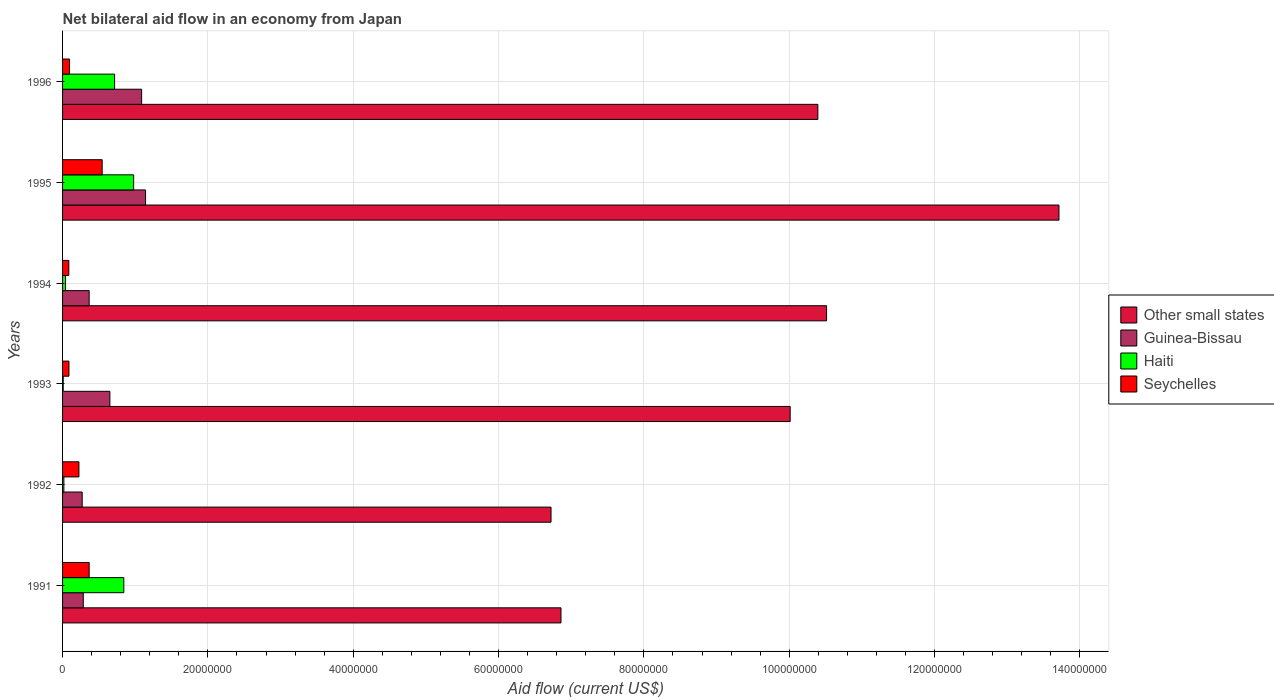How many different coloured bars are there?
Offer a terse response. 4. Are the number of bars per tick equal to the number of legend labels?
Provide a succinct answer. Yes. Are the number of bars on each tick of the Y-axis equal?
Offer a terse response. Yes. How many bars are there on the 3rd tick from the top?
Your answer should be very brief. 4. In how many cases, is the number of bars for a given year not equal to the number of legend labels?
Your answer should be compact. 0. What is the net bilateral aid flow in Haiti in 1995?
Make the answer very short. 9.78e+06. Across all years, what is the maximum net bilateral aid flow in Haiti?
Your answer should be compact. 9.78e+06. Across all years, what is the minimum net bilateral aid flow in Seychelles?
Keep it short and to the point. 8.60e+05. In which year was the net bilateral aid flow in Guinea-Bissau maximum?
Offer a terse response. 1995. What is the total net bilateral aid flow in Other small states in the graph?
Offer a terse response. 5.82e+08. What is the difference between the net bilateral aid flow in Seychelles in 1991 and that in 1995?
Make the answer very short. -1.79e+06. What is the difference between the net bilateral aid flow in Haiti in 1992 and the net bilateral aid flow in Other small states in 1994?
Offer a very short reply. -1.05e+08. What is the average net bilateral aid flow in Guinea-Bissau per year?
Keep it short and to the point. 6.34e+06. In the year 1991, what is the difference between the net bilateral aid flow in Other small states and net bilateral aid flow in Haiti?
Give a very brief answer. 6.02e+07. What is the ratio of the net bilateral aid flow in Haiti in 1991 to that in 1994?
Your answer should be compact. 20.56. What is the difference between the highest and the second highest net bilateral aid flow in Guinea-Bissau?
Provide a short and direct response. 5.40e+05. What is the difference between the highest and the lowest net bilateral aid flow in Seychelles?
Provide a succinct answer. 4.59e+06. In how many years, is the net bilateral aid flow in Other small states greater than the average net bilateral aid flow in Other small states taken over all years?
Provide a short and direct response. 4. Is the sum of the net bilateral aid flow in Guinea-Bissau in 1993 and 1994 greater than the maximum net bilateral aid flow in Other small states across all years?
Ensure brevity in your answer.  No. What does the 2nd bar from the top in 1996 represents?
Make the answer very short. Haiti. What does the 4th bar from the bottom in 1992 represents?
Offer a very short reply. Seychelles. Are all the bars in the graph horizontal?
Ensure brevity in your answer.  Yes. How many years are there in the graph?
Provide a succinct answer. 6. Does the graph contain any zero values?
Offer a very short reply. No. How are the legend labels stacked?
Your response must be concise. Vertical. What is the title of the graph?
Make the answer very short. Net bilateral aid flow in an economy from Japan. What is the label or title of the Y-axis?
Your answer should be very brief. Years. What is the Aid flow (current US$) in Other small states in 1991?
Your answer should be very brief. 6.86e+07. What is the Aid flow (current US$) of Guinea-Bissau in 1991?
Your answer should be very brief. 2.85e+06. What is the Aid flow (current US$) in Haiti in 1991?
Offer a terse response. 8.43e+06. What is the Aid flow (current US$) of Seychelles in 1991?
Give a very brief answer. 3.66e+06. What is the Aid flow (current US$) in Other small states in 1992?
Your answer should be compact. 6.72e+07. What is the Aid flow (current US$) of Guinea-Bissau in 1992?
Make the answer very short. 2.70e+06. What is the Aid flow (current US$) of Haiti in 1992?
Make the answer very short. 1.80e+05. What is the Aid flow (current US$) of Seychelles in 1992?
Offer a very short reply. 2.25e+06. What is the Aid flow (current US$) in Other small states in 1993?
Offer a terse response. 1.00e+08. What is the Aid flow (current US$) in Guinea-Bissau in 1993?
Offer a very short reply. 6.51e+06. What is the Aid flow (current US$) of Haiti in 1993?
Provide a succinct answer. 9.00e+04. What is the Aid flow (current US$) in Seychelles in 1993?
Your answer should be very brief. 8.80e+05. What is the Aid flow (current US$) of Other small states in 1994?
Give a very brief answer. 1.05e+08. What is the Aid flow (current US$) in Guinea-Bissau in 1994?
Give a very brief answer. 3.66e+06. What is the Aid flow (current US$) in Haiti in 1994?
Ensure brevity in your answer.  4.10e+05. What is the Aid flow (current US$) of Seychelles in 1994?
Provide a short and direct response. 8.60e+05. What is the Aid flow (current US$) in Other small states in 1995?
Provide a short and direct response. 1.37e+08. What is the Aid flow (current US$) of Guinea-Bissau in 1995?
Keep it short and to the point. 1.14e+07. What is the Aid flow (current US$) of Haiti in 1995?
Give a very brief answer. 9.78e+06. What is the Aid flow (current US$) of Seychelles in 1995?
Keep it short and to the point. 5.45e+06. What is the Aid flow (current US$) of Other small states in 1996?
Offer a terse response. 1.04e+08. What is the Aid flow (current US$) of Guinea-Bissau in 1996?
Offer a terse response. 1.09e+07. What is the Aid flow (current US$) of Haiti in 1996?
Keep it short and to the point. 7.16e+06. What is the Aid flow (current US$) of Seychelles in 1996?
Offer a very short reply. 9.60e+05. Across all years, what is the maximum Aid flow (current US$) in Other small states?
Make the answer very short. 1.37e+08. Across all years, what is the maximum Aid flow (current US$) in Guinea-Bissau?
Keep it short and to the point. 1.14e+07. Across all years, what is the maximum Aid flow (current US$) in Haiti?
Your response must be concise. 9.78e+06. Across all years, what is the maximum Aid flow (current US$) of Seychelles?
Offer a terse response. 5.45e+06. Across all years, what is the minimum Aid flow (current US$) of Other small states?
Offer a terse response. 6.72e+07. Across all years, what is the minimum Aid flow (current US$) of Guinea-Bissau?
Your answer should be very brief. 2.70e+06. Across all years, what is the minimum Aid flow (current US$) of Haiti?
Offer a very short reply. 9.00e+04. Across all years, what is the minimum Aid flow (current US$) in Seychelles?
Your response must be concise. 8.60e+05. What is the total Aid flow (current US$) of Other small states in the graph?
Offer a terse response. 5.82e+08. What is the total Aid flow (current US$) in Guinea-Bissau in the graph?
Ensure brevity in your answer.  3.80e+07. What is the total Aid flow (current US$) in Haiti in the graph?
Provide a short and direct response. 2.60e+07. What is the total Aid flow (current US$) of Seychelles in the graph?
Your response must be concise. 1.41e+07. What is the difference between the Aid flow (current US$) in Other small states in 1991 and that in 1992?
Your response must be concise. 1.37e+06. What is the difference between the Aid flow (current US$) in Haiti in 1991 and that in 1992?
Provide a short and direct response. 8.25e+06. What is the difference between the Aid flow (current US$) of Seychelles in 1991 and that in 1992?
Give a very brief answer. 1.41e+06. What is the difference between the Aid flow (current US$) of Other small states in 1991 and that in 1993?
Your answer should be very brief. -3.15e+07. What is the difference between the Aid flow (current US$) of Guinea-Bissau in 1991 and that in 1993?
Keep it short and to the point. -3.66e+06. What is the difference between the Aid flow (current US$) in Haiti in 1991 and that in 1993?
Make the answer very short. 8.34e+06. What is the difference between the Aid flow (current US$) of Seychelles in 1991 and that in 1993?
Your answer should be very brief. 2.78e+06. What is the difference between the Aid flow (current US$) in Other small states in 1991 and that in 1994?
Offer a very short reply. -3.66e+07. What is the difference between the Aid flow (current US$) in Guinea-Bissau in 1991 and that in 1994?
Offer a terse response. -8.10e+05. What is the difference between the Aid flow (current US$) of Haiti in 1991 and that in 1994?
Keep it short and to the point. 8.02e+06. What is the difference between the Aid flow (current US$) in Seychelles in 1991 and that in 1994?
Keep it short and to the point. 2.80e+06. What is the difference between the Aid flow (current US$) in Other small states in 1991 and that in 1995?
Provide a short and direct response. -6.85e+07. What is the difference between the Aid flow (current US$) in Guinea-Bissau in 1991 and that in 1995?
Provide a short and direct response. -8.57e+06. What is the difference between the Aid flow (current US$) in Haiti in 1991 and that in 1995?
Your response must be concise. -1.35e+06. What is the difference between the Aid flow (current US$) of Seychelles in 1991 and that in 1995?
Give a very brief answer. -1.79e+06. What is the difference between the Aid flow (current US$) of Other small states in 1991 and that in 1996?
Make the answer very short. -3.54e+07. What is the difference between the Aid flow (current US$) of Guinea-Bissau in 1991 and that in 1996?
Ensure brevity in your answer.  -8.03e+06. What is the difference between the Aid flow (current US$) in Haiti in 1991 and that in 1996?
Your answer should be compact. 1.27e+06. What is the difference between the Aid flow (current US$) of Seychelles in 1991 and that in 1996?
Your response must be concise. 2.70e+06. What is the difference between the Aid flow (current US$) of Other small states in 1992 and that in 1993?
Provide a succinct answer. -3.29e+07. What is the difference between the Aid flow (current US$) of Guinea-Bissau in 1992 and that in 1993?
Provide a short and direct response. -3.81e+06. What is the difference between the Aid flow (current US$) of Haiti in 1992 and that in 1993?
Keep it short and to the point. 9.00e+04. What is the difference between the Aid flow (current US$) in Seychelles in 1992 and that in 1993?
Make the answer very short. 1.37e+06. What is the difference between the Aid flow (current US$) in Other small states in 1992 and that in 1994?
Offer a terse response. -3.79e+07. What is the difference between the Aid flow (current US$) in Guinea-Bissau in 1992 and that in 1994?
Give a very brief answer. -9.60e+05. What is the difference between the Aid flow (current US$) of Seychelles in 1992 and that in 1994?
Provide a succinct answer. 1.39e+06. What is the difference between the Aid flow (current US$) of Other small states in 1992 and that in 1995?
Provide a succinct answer. -6.99e+07. What is the difference between the Aid flow (current US$) in Guinea-Bissau in 1992 and that in 1995?
Provide a succinct answer. -8.72e+06. What is the difference between the Aid flow (current US$) of Haiti in 1992 and that in 1995?
Ensure brevity in your answer.  -9.60e+06. What is the difference between the Aid flow (current US$) of Seychelles in 1992 and that in 1995?
Make the answer very short. -3.20e+06. What is the difference between the Aid flow (current US$) of Other small states in 1992 and that in 1996?
Provide a short and direct response. -3.67e+07. What is the difference between the Aid flow (current US$) in Guinea-Bissau in 1992 and that in 1996?
Ensure brevity in your answer.  -8.18e+06. What is the difference between the Aid flow (current US$) in Haiti in 1992 and that in 1996?
Provide a succinct answer. -6.98e+06. What is the difference between the Aid flow (current US$) of Seychelles in 1992 and that in 1996?
Keep it short and to the point. 1.29e+06. What is the difference between the Aid flow (current US$) of Other small states in 1993 and that in 1994?
Ensure brevity in your answer.  -5.01e+06. What is the difference between the Aid flow (current US$) in Guinea-Bissau in 1993 and that in 1994?
Provide a succinct answer. 2.85e+06. What is the difference between the Aid flow (current US$) in Haiti in 1993 and that in 1994?
Keep it short and to the point. -3.20e+05. What is the difference between the Aid flow (current US$) in Seychelles in 1993 and that in 1994?
Your response must be concise. 2.00e+04. What is the difference between the Aid flow (current US$) of Other small states in 1993 and that in 1995?
Ensure brevity in your answer.  -3.70e+07. What is the difference between the Aid flow (current US$) of Guinea-Bissau in 1993 and that in 1995?
Provide a succinct answer. -4.91e+06. What is the difference between the Aid flow (current US$) of Haiti in 1993 and that in 1995?
Give a very brief answer. -9.69e+06. What is the difference between the Aid flow (current US$) of Seychelles in 1993 and that in 1995?
Your answer should be very brief. -4.57e+06. What is the difference between the Aid flow (current US$) of Other small states in 1993 and that in 1996?
Provide a short and direct response. -3.81e+06. What is the difference between the Aid flow (current US$) of Guinea-Bissau in 1993 and that in 1996?
Your answer should be very brief. -4.37e+06. What is the difference between the Aid flow (current US$) of Haiti in 1993 and that in 1996?
Your answer should be compact. -7.07e+06. What is the difference between the Aid flow (current US$) in Seychelles in 1993 and that in 1996?
Ensure brevity in your answer.  -8.00e+04. What is the difference between the Aid flow (current US$) of Other small states in 1994 and that in 1995?
Your answer should be compact. -3.20e+07. What is the difference between the Aid flow (current US$) of Guinea-Bissau in 1994 and that in 1995?
Provide a short and direct response. -7.76e+06. What is the difference between the Aid flow (current US$) in Haiti in 1994 and that in 1995?
Give a very brief answer. -9.37e+06. What is the difference between the Aid flow (current US$) in Seychelles in 1994 and that in 1995?
Keep it short and to the point. -4.59e+06. What is the difference between the Aid flow (current US$) of Other small states in 1994 and that in 1996?
Provide a succinct answer. 1.20e+06. What is the difference between the Aid flow (current US$) of Guinea-Bissau in 1994 and that in 1996?
Ensure brevity in your answer.  -7.22e+06. What is the difference between the Aid flow (current US$) of Haiti in 1994 and that in 1996?
Offer a terse response. -6.75e+06. What is the difference between the Aid flow (current US$) in Other small states in 1995 and that in 1996?
Offer a terse response. 3.32e+07. What is the difference between the Aid flow (current US$) in Guinea-Bissau in 1995 and that in 1996?
Ensure brevity in your answer.  5.40e+05. What is the difference between the Aid flow (current US$) in Haiti in 1995 and that in 1996?
Make the answer very short. 2.62e+06. What is the difference between the Aid flow (current US$) of Seychelles in 1995 and that in 1996?
Make the answer very short. 4.49e+06. What is the difference between the Aid flow (current US$) in Other small states in 1991 and the Aid flow (current US$) in Guinea-Bissau in 1992?
Your response must be concise. 6.59e+07. What is the difference between the Aid flow (current US$) in Other small states in 1991 and the Aid flow (current US$) in Haiti in 1992?
Offer a terse response. 6.84e+07. What is the difference between the Aid flow (current US$) of Other small states in 1991 and the Aid flow (current US$) of Seychelles in 1992?
Offer a terse response. 6.63e+07. What is the difference between the Aid flow (current US$) of Guinea-Bissau in 1991 and the Aid flow (current US$) of Haiti in 1992?
Your answer should be compact. 2.67e+06. What is the difference between the Aid flow (current US$) of Haiti in 1991 and the Aid flow (current US$) of Seychelles in 1992?
Offer a very short reply. 6.18e+06. What is the difference between the Aid flow (current US$) of Other small states in 1991 and the Aid flow (current US$) of Guinea-Bissau in 1993?
Give a very brief answer. 6.21e+07. What is the difference between the Aid flow (current US$) in Other small states in 1991 and the Aid flow (current US$) in Haiti in 1993?
Give a very brief answer. 6.85e+07. What is the difference between the Aid flow (current US$) of Other small states in 1991 and the Aid flow (current US$) of Seychelles in 1993?
Make the answer very short. 6.77e+07. What is the difference between the Aid flow (current US$) in Guinea-Bissau in 1991 and the Aid flow (current US$) in Haiti in 1993?
Keep it short and to the point. 2.76e+06. What is the difference between the Aid flow (current US$) of Guinea-Bissau in 1991 and the Aid flow (current US$) of Seychelles in 1993?
Your response must be concise. 1.97e+06. What is the difference between the Aid flow (current US$) of Haiti in 1991 and the Aid flow (current US$) of Seychelles in 1993?
Your response must be concise. 7.55e+06. What is the difference between the Aid flow (current US$) of Other small states in 1991 and the Aid flow (current US$) of Guinea-Bissau in 1994?
Your answer should be compact. 6.49e+07. What is the difference between the Aid flow (current US$) in Other small states in 1991 and the Aid flow (current US$) in Haiti in 1994?
Ensure brevity in your answer.  6.82e+07. What is the difference between the Aid flow (current US$) of Other small states in 1991 and the Aid flow (current US$) of Seychelles in 1994?
Provide a short and direct response. 6.77e+07. What is the difference between the Aid flow (current US$) in Guinea-Bissau in 1991 and the Aid flow (current US$) in Haiti in 1994?
Offer a terse response. 2.44e+06. What is the difference between the Aid flow (current US$) of Guinea-Bissau in 1991 and the Aid flow (current US$) of Seychelles in 1994?
Provide a short and direct response. 1.99e+06. What is the difference between the Aid flow (current US$) of Haiti in 1991 and the Aid flow (current US$) of Seychelles in 1994?
Offer a very short reply. 7.57e+06. What is the difference between the Aid flow (current US$) of Other small states in 1991 and the Aid flow (current US$) of Guinea-Bissau in 1995?
Give a very brief answer. 5.72e+07. What is the difference between the Aid flow (current US$) of Other small states in 1991 and the Aid flow (current US$) of Haiti in 1995?
Ensure brevity in your answer.  5.88e+07. What is the difference between the Aid flow (current US$) of Other small states in 1991 and the Aid flow (current US$) of Seychelles in 1995?
Give a very brief answer. 6.31e+07. What is the difference between the Aid flow (current US$) in Guinea-Bissau in 1991 and the Aid flow (current US$) in Haiti in 1995?
Keep it short and to the point. -6.93e+06. What is the difference between the Aid flow (current US$) of Guinea-Bissau in 1991 and the Aid flow (current US$) of Seychelles in 1995?
Offer a very short reply. -2.60e+06. What is the difference between the Aid flow (current US$) of Haiti in 1991 and the Aid flow (current US$) of Seychelles in 1995?
Offer a terse response. 2.98e+06. What is the difference between the Aid flow (current US$) in Other small states in 1991 and the Aid flow (current US$) in Guinea-Bissau in 1996?
Keep it short and to the point. 5.77e+07. What is the difference between the Aid flow (current US$) in Other small states in 1991 and the Aid flow (current US$) in Haiti in 1996?
Your response must be concise. 6.14e+07. What is the difference between the Aid flow (current US$) of Other small states in 1991 and the Aid flow (current US$) of Seychelles in 1996?
Your response must be concise. 6.76e+07. What is the difference between the Aid flow (current US$) in Guinea-Bissau in 1991 and the Aid flow (current US$) in Haiti in 1996?
Your answer should be very brief. -4.31e+06. What is the difference between the Aid flow (current US$) in Guinea-Bissau in 1991 and the Aid flow (current US$) in Seychelles in 1996?
Offer a terse response. 1.89e+06. What is the difference between the Aid flow (current US$) in Haiti in 1991 and the Aid flow (current US$) in Seychelles in 1996?
Your answer should be very brief. 7.47e+06. What is the difference between the Aid flow (current US$) in Other small states in 1992 and the Aid flow (current US$) in Guinea-Bissau in 1993?
Give a very brief answer. 6.07e+07. What is the difference between the Aid flow (current US$) of Other small states in 1992 and the Aid flow (current US$) of Haiti in 1993?
Provide a succinct answer. 6.71e+07. What is the difference between the Aid flow (current US$) of Other small states in 1992 and the Aid flow (current US$) of Seychelles in 1993?
Your answer should be compact. 6.63e+07. What is the difference between the Aid flow (current US$) in Guinea-Bissau in 1992 and the Aid flow (current US$) in Haiti in 1993?
Keep it short and to the point. 2.61e+06. What is the difference between the Aid flow (current US$) in Guinea-Bissau in 1992 and the Aid flow (current US$) in Seychelles in 1993?
Ensure brevity in your answer.  1.82e+06. What is the difference between the Aid flow (current US$) in Haiti in 1992 and the Aid flow (current US$) in Seychelles in 1993?
Give a very brief answer. -7.00e+05. What is the difference between the Aid flow (current US$) in Other small states in 1992 and the Aid flow (current US$) in Guinea-Bissau in 1994?
Provide a short and direct response. 6.36e+07. What is the difference between the Aid flow (current US$) in Other small states in 1992 and the Aid flow (current US$) in Haiti in 1994?
Make the answer very short. 6.68e+07. What is the difference between the Aid flow (current US$) in Other small states in 1992 and the Aid flow (current US$) in Seychelles in 1994?
Your answer should be very brief. 6.64e+07. What is the difference between the Aid flow (current US$) of Guinea-Bissau in 1992 and the Aid flow (current US$) of Haiti in 1994?
Ensure brevity in your answer.  2.29e+06. What is the difference between the Aid flow (current US$) in Guinea-Bissau in 1992 and the Aid flow (current US$) in Seychelles in 1994?
Provide a succinct answer. 1.84e+06. What is the difference between the Aid flow (current US$) of Haiti in 1992 and the Aid flow (current US$) of Seychelles in 1994?
Offer a very short reply. -6.80e+05. What is the difference between the Aid flow (current US$) in Other small states in 1992 and the Aid flow (current US$) in Guinea-Bissau in 1995?
Give a very brief answer. 5.58e+07. What is the difference between the Aid flow (current US$) of Other small states in 1992 and the Aid flow (current US$) of Haiti in 1995?
Offer a terse response. 5.74e+07. What is the difference between the Aid flow (current US$) of Other small states in 1992 and the Aid flow (current US$) of Seychelles in 1995?
Provide a short and direct response. 6.18e+07. What is the difference between the Aid flow (current US$) in Guinea-Bissau in 1992 and the Aid flow (current US$) in Haiti in 1995?
Keep it short and to the point. -7.08e+06. What is the difference between the Aid flow (current US$) of Guinea-Bissau in 1992 and the Aid flow (current US$) of Seychelles in 1995?
Give a very brief answer. -2.75e+06. What is the difference between the Aid flow (current US$) in Haiti in 1992 and the Aid flow (current US$) in Seychelles in 1995?
Ensure brevity in your answer.  -5.27e+06. What is the difference between the Aid flow (current US$) in Other small states in 1992 and the Aid flow (current US$) in Guinea-Bissau in 1996?
Keep it short and to the point. 5.63e+07. What is the difference between the Aid flow (current US$) of Other small states in 1992 and the Aid flow (current US$) of Haiti in 1996?
Provide a short and direct response. 6.01e+07. What is the difference between the Aid flow (current US$) of Other small states in 1992 and the Aid flow (current US$) of Seychelles in 1996?
Provide a short and direct response. 6.63e+07. What is the difference between the Aid flow (current US$) of Guinea-Bissau in 1992 and the Aid flow (current US$) of Haiti in 1996?
Provide a succinct answer. -4.46e+06. What is the difference between the Aid flow (current US$) in Guinea-Bissau in 1992 and the Aid flow (current US$) in Seychelles in 1996?
Your answer should be very brief. 1.74e+06. What is the difference between the Aid flow (current US$) of Haiti in 1992 and the Aid flow (current US$) of Seychelles in 1996?
Your answer should be compact. -7.80e+05. What is the difference between the Aid flow (current US$) of Other small states in 1993 and the Aid flow (current US$) of Guinea-Bissau in 1994?
Keep it short and to the point. 9.65e+07. What is the difference between the Aid flow (current US$) in Other small states in 1993 and the Aid flow (current US$) in Haiti in 1994?
Keep it short and to the point. 9.97e+07. What is the difference between the Aid flow (current US$) in Other small states in 1993 and the Aid flow (current US$) in Seychelles in 1994?
Give a very brief answer. 9.93e+07. What is the difference between the Aid flow (current US$) in Guinea-Bissau in 1993 and the Aid flow (current US$) in Haiti in 1994?
Provide a short and direct response. 6.10e+06. What is the difference between the Aid flow (current US$) of Guinea-Bissau in 1993 and the Aid flow (current US$) of Seychelles in 1994?
Your answer should be very brief. 5.65e+06. What is the difference between the Aid flow (current US$) in Haiti in 1993 and the Aid flow (current US$) in Seychelles in 1994?
Offer a terse response. -7.70e+05. What is the difference between the Aid flow (current US$) of Other small states in 1993 and the Aid flow (current US$) of Guinea-Bissau in 1995?
Give a very brief answer. 8.87e+07. What is the difference between the Aid flow (current US$) of Other small states in 1993 and the Aid flow (current US$) of Haiti in 1995?
Provide a succinct answer. 9.04e+07. What is the difference between the Aid flow (current US$) in Other small states in 1993 and the Aid flow (current US$) in Seychelles in 1995?
Provide a succinct answer. 9.47e+07. What is the difference between the Aid flow (current US$) in Guinea-Bissau in 1993 and the Aid flow (current US$) in Haiti in 1995?
Ensure brevity in your answer.  -3.27e+06. What is the difference between the Aid flow (current US$) in Guinea-Bissau in 1993 and the Aid flow (current US$) in Seychelles in 1995?
Offer a terse response. 1.06e+06. What is the difference between the Aid flow (current US$) of Haiti in 1993 and the Aid flow (current US$) of Seychelles in 1995?
Offer a terse response. -5.36e+06. What is the difference between the Aid flow (current US$) in Other small states in 1993 and the Aid flow (current US$) in Guinea-Bissau in 1996?
Offer a terse response. 8.92e+07. What is the difference between the Aid flow (current US$) in Other small states in 1993 and the Aid flow (current US$) in Haiti in 1996?
Keep it short and to the point. 9.30e+07. What is the difference between the Aid flow (current US$) in Other small states in 1993 and the Aid flow (current US$) in Seychelles in 1996?
Keep it short and to the point. 9.92e+07. What is the difference between the Aid flow (current US$) of Guinea-Bissau in 1993 and the Aid flow (current US$) of Haiti in 1996?
Offer a very short reply. -6.50e+05. What is the difference between the Aid flow (current US$) in Guinea-Bissau in 1993 and the Aid flow (current US$) in Seychelles in 1996?
Provide a succinct answer. 5.55e+06. What is the difference between the Aid flow (current US$) of Haiti in 1993 and the Aid flow (current US$) of Seychelles in 1996?
Your answer should be compact. -8.70e+05. What is the difference between the Aid flow (current US$) in Other small states in 1994 and the Aid flow (current US$) in Guinea-Bissau in 1995?
Provide a succinct answer. 9.37e+07. What is the difference between the Aid flow (current US$) in Other small states in 1994 and the Aid flow (current US$) in Haiti in 1995?
Your answer should be compact. 9.54e+07. What is the difference between the Aid flow (current US$) in Other small states in 1994 and the Aid flow (current US$) in Seychelles in 1995?
Keep it short and to the point. 9.97e+07. What is the difference between the Aid flow (current US$) in Guinea-Bissau in 1994 and the Aid flow (current US$) in Haiti in 1995?
Your response must be concise. -6.12e+06. What is the difference between the Aid flow (current US$) of Guinea-Bissau in 1994 and the Aid flow (current US$) of Seychelles in 1995?
Offer a very short reply. -1.79e+06. What is the difference between the Aid flow (current US$) of Haiti in 1994 and the Aid flow (current US$) of Seychelles in 1995?
Offer a terse response. -5.04e+06. What is the difference between the Aid flow (current US$) in Other small states in 1994 and the Aid flow (current US$) in Guinea-Bissau in 1996?
Provide a succinct answer. 9.43e+07. What is the difference between the Aid flow (current US$) in Other small states in 1994 and the Aid flow (current US$) in Haiti in 1996?
Provide a succinct answer. 9.80e+07. What is the difference between the Aid flow (current US$) in Other small states in 1994 and the Aid flow (current US$) in Seychelles in 1996?
Keep it short and to the point. 1.04e+08. What is the difference between the Aid flow (current US$) of Guinea-Bissau in 1994 and the Aid flow (current US$) of Haiti in 1996?
Offer a very short reply. -3.50e+06. What is the difference between the Aid flow (current US$) in Guinea-Bissau in 1994 and the Aid flow (current US$) in Seychelles in 1996?
Offer a terse response. 2.70e+06. What is the difference between the Aid flow (current US$) in Haiti in 1994 and the Aid flow (current US$) in Seychelles in 1996?
Offer a very short reply. -5.50e+05. What is the difference between the Aid flow (current US$) of Other small states in 1995 and the Aid flow (current US$) of Guinea-Bissau in 1996?
Your response must be concise. 1.26e+08. What is the difference between the Aid flow (current US$) in Other small states in 1995 and the Aid flow (current US$) in Haiti in 1996?
Keep it short and to the point. 1.30e+08. What is the difference between the Aid flow (current US$) in Other small states in 1995 and the Aid flow (current US$) in Seychelles in 1996?
Your response must be concise. 1.36e+08. What is the difference between the Aid flow (current US$) in Guinea-Bissau in 1995 and the Aid flow (current US$) in Haiti in 1996?
Keep it short and to the point. 4.26e+06. What is the difference between the Aid flow (current US$) in Guinea-Bissau in 1995 and the Aid flow (current US$) in Seychelles in 1996?
Provide a succinct answer. 1.05e+07. What is the difference between the Aid flow (current US$) in Haiti in 1995 and the Aid flow (current US$) in Seychelles in 1996?
Keep it short and to the point. 8.82e+06. What is the average Aid flow (current US$) of Other small states per year?
Give a very brief answer. 9.70e+07. What is the average Aid flow (current US$) of Guinea-Bissau per year?
Keep it short and to the point. 6.34e+06. What is the average Aid flow (current US$) of Haiti per year?
Provide a short and direct response. 4.34e+06. What is the average Aid flow (current US$) in Seychelles per year?
Offer a very short reply. 2.34e+06. In the year 1991, what is the difference between the Aid flow (current US$) of Other small states and Aid flow (current US$) of Guinea-Bissau?
Provide a short and direct response. 6.57e+07. In the year 1991, what is the difference between the Aid flow (current US$) of Other small states and Aid flow (current US$) of Haiti?
Your answer should be very brief. 6.02e+07. In the year 1991, what is the difference between the Aid flow (current US$) in Other small states and Aid flow (current US$) in Seychelles?
Your answer should be compact. 6.49e+07. In the year 1991, what is the difference between the Aid flow (current US$) in Guinea-Bissau and Aid flow (current US$) in Haiti?
Offer a very short reply. -5.58e+06. In the year 1991, what is the difference between the Aid flow (current US$) of Guinea-Bissau and Aid flow (current US$) of Seychelles?
Give a very brief answer. -8.10e+05. In the year 1991, what is the difference between the Aid flow (current US$) in Haiti and Aid flow (current US$) in Seychelles?
Give a very brief answer. 4.77e+06. In the year 1992, what is the difference between the Aid flow (current US$) in Other small states and Aid flow (current US$) in Guinea-Bissau?
Your answer should be very brief. 6.45e+07. In the year 1992, what is the difference between the Aid flow (current US$) of Other small states and Aid flow (current US$) of Haiti?
Provide a short and direct response. 6.70e+07. In the year 1992, what is the difference between the Aid flow (current US$) of Other small states and Aid flow (current US$) of Seychelles?
Give a very brief answer. 6.50e+07. In the year 1992, what is the difference between the Aid flow (current US$) of Guinea-Bissau and Aid flow (current US$) of Haiti?
Give a very brief answer. 2.52e+06. In the year 1992, what is the difference between the Aid flow (current US$) of Haiti and Aid flow (current US$) of Seychelles?
Provide a short and direct response. -2.07e+06. In the year 1993, what is the difference between the Aid flow (current US$) of Other small states and Aid flow (current US$) of Guinea-Bissau?
Offer a terse response. 9.36e+07. In the year 1993, what is the difference between the Aid flow (current US$) in Other small states and Aid flow (current US$) in Haiti?
Your answer should be compact. 1.00e+08. In the year 1993, what is the difference between the Aid flow (current US$) of Other small states and Aid flow (current US$) of Seychelles?
Your answer should be very brief. 9.92e+07. In the year 1993, what is the difference between the Aid flow (current US$) in Guinea-Bissau and Aid flow (current US$) in Haiti?
Your answer should be compact. 6.42e+06. In the year 1993, what is the difference between the Aid flow (current US$) in Guinea-Bissau and Aid flow (current US$) in Seychelles?
Your answer should be compact. 5.63e+06. In the year 1993, what is the difference between the Aid flow (current US$) in Haiti and Aid flow (current US$) in Seychelles?
Ensure brevity in your answer.  -7.90e+05. In the year 1994, what is the difference between the Aid flow (current US$) in Other small states and Aid flow (current US$) in Guinea-Bissau?
Provide a short and direct response. 1.01e+08. In the year 1994, what is the difference between the Aid flow (current US$) of Other small states and Aid flow (current US$) of Haiti?
Your answer should be very brief. 1.05e+08. In the year 1994, what is the difference between the Aid flow (current US$) of Other small states and Aid flow (current US$) of Seychelles?
Ensure brevity in your answer.  1.04e+08. In the year 1994, what is the difference between the Aid flow (current US$) of Guinea-Bissau and Aid flow (current US$) of Haiti?
Make the answer very short. 3.25e+06. In the year 1994, what is the difference between the Aid flow (current US$) in Guinea-Bissau and Aid flow (current US$) in Seychelles?
Offer a very short reply. 2.80e+06. In the year 1994, what is the difference between the Aid flow (current US$) of Haiti and Aid flow (current US$) of Seychelles?
Give a very brief answer. -4.50e+05. In the year 1995, what is the difference between the Aid flow (current US$) in Other small states and Aid flow (current US$) in Guinea-Bissau?
Your answer should be very brief. 1.26e+08. In the year 1995, what is the difference between the Aid flow (current US$) in Other small states and Aid flow (current US$) in Haiti?
Make the answer very short. 1.27e+08. In the year 1995, what is the difference between the Aid flow (current US$) in Other small states and Aid flow (current US$) in Seychelles?
Provide a short and direct response. 1.32e+08. In the year 1995, what is the difference between the Aid flow (current US$) of Guinea-Bissau and Aid flow (current US$) of Haiti?
Offer a very short reply. 1.64e+06. In the year 1995, what is the difference between the Aid flow (current US$) in Guinea-Bissau and Aid flow (current US$) in Seychelles?
Offer a very short reply. 5.97e+06. In the year 1995, what is the difference between the Aid flow (current US$) in Haiti and Aid flow (current US$) in Seychelles?
Give a very brief answer. 4.33e+06. In the year 1996, what is the difference between the Aid flow (current US$) in Other small states and Aid flow (current US$) in Guinea-Bissau?
Offer a very short reply. 9.31e+07. In the year 1996, what is the difference between the Aid flow (current US$) in Other small states and Aid flow (current US$) in Haiti?
Provide a succinct answer. 9.68e+07. In the year 1996, what is the difference between the Aid flow (current US$) in Other small states and Aid flow (current US$) in Seychelles?
Provide a succinct answer. 1.03e+08. In the year 1996, what is the difference between the Aid flow (current US$) in Guinea-Bissau and Aid flow (current US$) in Haiti?
Your response must be concise. 3.72e+06. In the year 1996, what is the difference between the Aid flow (current US$) in Guinea-Bissau and Aid flow (current US$) in Seychelles?
Your response must be concise. 9.92e+06. In the year 1996, what is the difference between the Aid flow (current US$) of Haiti and Aid flow (current US$) of Seychelles?
Make the answer very short. 6.20e+06. What is the ratio of the Aid flow (current US$) in Other small states in 1991 to that in 1992?
Offer a very short reply. 1.02. What is the ratio of the Aid flow (current US$) in Guinea-Bissau in 1991 to that in 1992?
Ensure brevity in your answer.  1.06. What is the ratio of the Aid flow (current US$) in Haiti in 1991 to that in 1992?
Provide a succinct answer. 46.83. What is the ratio of the Aid flow (current US$) of Seychelles in 1991 to that in 1992?
Make the answer very short. 1.63. What is the ratio of the Aid flow (current US$) in Other small states in 1991 to that in 1993?
Make the answer very short. 0.69. What is the ratio of the Aid flow (current US$) of Guinea-Bissau in 1991 to that in 1993?
Your response must be concise. 0.44. What is the ratio of the Aid flow (current US$) of Haiti in 1991 to that in 1993?
Keep it short and to the point. 93.67. What is the ratio of the Aid flow (current US$) of Seychelles in 1991 to that in 1993?
Your answer should be very brief. 4.16. What is the ratio of the Aid flow (current US$) of Other small states in 1991 to that in 1994?
Make the answer very short. 0.65. What is the ratio of the Aid flow (current US$) of Guinea-Bissau in 1991 to that in 1994?
Your answer should be very brief. 0.78. What is the ratio of the Aid flow (current US$) in Haiti in 1991 to that in 1994?
Offer a very short reply. 20.56. What is the ratio of the Aid flow (current US$) of Seychelles in 1991 to that in 1994?
Provide a short and direct response. 4.26. What is the ratio of the Aid flow (current US$) in Other small states in 1991 to that in 1995?
Offer a very short reply. 0.5. What is the ratio of the Aid flow (current US$) in Guinea-Bissau in 1991 to that in 1995?
Keep it short and to the point. 0.25. What is the ratio of the Aid flow (current US$) in Haiti in 1991 to that in 1995?
Ensure brevity in your answer.  0.86. What is the ratio of the Aid flow (current US$) in Seychelles in 1991 to that in 1995?
Provide a succinct answer. 0.67. What is the ratio of the Aid flow (current US$) of Other small states in 1991 to that in 1996?
Offer a very short reply. 0.66. What is the ratio of the Aid flow (current US$) in Guinea-Bissau in 1991 to that in 1996?
Make the answer very short. 0.26. What is the ratio of the Aid flow (current US$) of Haiti in 1991 to that in 1996?
Provide a short and direct response. 1.18. What is the ratio of the Aid flow (current US$) of Seychelles in 1991 to that in 1996?
Provide a succinct answer. 3.81. What is the ratio of the Aid flow (current US$) in Other small states in 1992 to that in 1993?
Your answer should be very brief. 0.67. What is the ratio of the Aid flow (current US$) of Guinea-Bissau in 1992 to that in 1993?
Offer a terse response. 0.41. What is the ratio of the Aid flow (current US$) of Seychelles in 1992 to that in 1993?
Your response must be concise. 2.56. What is the ratio of the Aid flow (current US$) in Other small states in 1992 to that in 1994?
Ensure brevity in your answer.  0.64. What is the ratio of the Aid flow (current US$) of Guinea-Bissau in 1992 to that in 1994?
Your answer should be compact. 0.74. What is the ratio of the Aid flow (current US$) in Haiti in 1992 to that in 1994?
Your response must be concise. 0.44. What is the ratio of the Aid flow (current US$) of Seychelles in 1992 to that in 1994?
Your answer should be very brief. 2.62. What is the ratio of the Aid flow (current US$) in Other small states in 1992 to that in 1995?
Provide a short and direct response. 0.49. What is the ratio of the Aid flow (current US$) in Guinea-Bissau in 1992 to that in 1995?
Ensure brevity in your answer.  0.24. What is the ratio of the Aid flow (current US$) in Haiti in 1992 to that in 1995?
Make the answer very short. 0.02. What is the ratio of the Aid flow (current US$) in Seychelles in 1992 to that in 1995?
Provide a short and direct response. 0.41. What is the ratio of the Aid flow (current US$) of Other small states in 1992 to that in 1996?
Ensure brevity in your answer.  0.65. What is the ratio of the Aid flow (current US$) of Guinea-Bissau in 1992 to that in 1996?
Offer a very short reply. 0.25. What is the ratio of the Aid flow (current US$) in Haiti in 1992 to that in 1996?
Offer a terse response. 0.03. What is the ratio of the Aid flow (current US$) in Seychelles in 1992 to that in 1996?
Offer a terse response. 2.34. What is the ratio of the Aid flow (current US$) in Other small states in 1993 to that in 1994?
Keep it short and to the point. 0.95. What is the ratio of the Aid flow (current US$) in Guinea-Bissau in 1993 to that in 1994?
Keep it short and to the point. 1.78. What is the ratio of the Aid flow (current US$) of Haiti in 1993 to that in 1994?
Offer a terse response. 0.22. What is the ratio of the Aid flow (current US$) of Seychelles in 1993 to that in 1994?
Your answer should be compact. 1.02. What is the ratio of the Aid flow (current US$) in Other small states in 1993 to that in 1995?
Offer a terse response. 0.73. What is the ratio of the Aid flow (current US$) in Guinea-Bissau in 1993 to that in 1995?
Ensure brevity in your answer.  0.57. What is the ratio of the Aid flow (current US$) in Haiti in 1993 to that in 1995?
Ensure brevity in your answer.  0.01. What is the ratio of the Aid flow (current US$) in Seychelles in 1993 to that in 1995?
Your response must be concise. 0.16. What is the ratio of the Aid flow (current US$) of Other small states in 1993 to that in 1996?
Give a very brief answer. 0.96. What is the ratio of the Aid flow (current US$) in Guinea-Bissau in 1993 to that in 1996?
Provide a short and direct response. 0.6. What is the ratio of the Aid flow (current US$) in Haiti in 1993 to that in 1996?
Keep it short and to the point. 0.01. What is the ratio of the Aid flow (current US$) of Seychelles in 1993 to that in 1996?
Your response must be concise. 0.92. What is the ratio of the Aid flow (current US$) in Other small states in 1994 to that in 1995?
Provide a succinct answer. 0.77. What is the ratio of the Aid flow (current US$) in Guinea-Bissau in 1994 to that in 1995?
Ensure brevity in your answer.  0.32. What is the ratio of the Aid flow (current US$) in Haiti in 1994 to that in 1995?
Offer a very short reply. 0.04. What is the ratio of the Aid flow (current US$) in Seychelles in 1994 to that in 1995?
Offer a very short reply. 0.16. What is the ratio of the Aid flow (current US$) of Other small states in 1994 to that in 1996?
Provide a succinct answer. 1.01. What is the ratio of the Aid flow (current US$) in Guinea-Bissau in 1994 to that in 1996?
Provide a short and direct response. 0.34. What is the ratio of the Aid flow (current US$) in Haiti in 1994 to that in 1996?
Make the answer very short. 0.06. What is the ratio of the Aid flow (current US$) in Seychelles in 1994 to that in 1996?
Your answer should be very brief. 0.9. What is the ratio of the Aid flow (current US$) of Other small states in 1995 to that in 1996?
Offer a very short reply. 1.32. What is the ratio of the Aid flow (current US$) in Guinea-Bissau in 1995 to that in 1996?
Offer a very short reply. 1.05. What is the ratio of the Aid flow (current US$) in Haiti in 1995 to that in 1996?
Provide a short and direct response. 1.37. What is the ratio of the Aid flow (current US$) of Seychelles in 1995 to that in 1996?
Offer a very short reply. 5.68. What is the difference between the highest and the second highest Aid flow (current US$) of Other small states?
Keep it short and to the point. 3.20e+07. What is the difference between the highest and the second highest Aid flow (current US$) in Guinea-Bissau?
Make the answer very short. 5.40e+05. What is the difference between the highest and the second highest Aid flow (current US$) in Haiti?
Give a very brief answer. 1.35e+06. What is the difference between the highest and the second highest Aid flow (current US$) of Seychelles?
Keep it short and to the point. 1.79e+06. What is the difference between the highest and the lowest Aid flow (current US$) in Other small states?
Ensure brevity in your answer.  6.99e+07. What is the difference between the highest and the lowest Aid flow (current US$) of Guinea-Bissau?
Provide a succinct answer. 8.72e+06. What is the difference between the highest and the lowest Aid flow (current US$) of Haiti?
Give a very brief answer. 9.69e+06. What is the difference between the highest and the lowest Aid flow (current US$) in Seychelles?
Make the answer very short. 4.59e+06. 